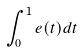Convert formula to latex. <formula><loc_0><loc_0><loc_500><loc_500>\int _ { 0 } ^ { 1 } e ( t ) d t</formula> 